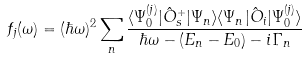<formula> <loc_0><loc_0><loc_500><loc_500>f _ { j } ( \omega ) = ( \hbar { \omega } ) ^ { 2 } \sum _ { n } \frac { \langle \Psi _ { 0 } ^ { ( j ) } | { \hat { O } } ^ { + } _ { s } | \Psi _ { n } \rangle \langle \Psi _ { n } | { \hat { O } _ { i } } | \Psi _ { 0 } ^ { ( j ) } \rangle } { \hbar { \omega } - ( E _ { n } - E _ { 0 } ) - i \Gamma _ { n } }</formula> 